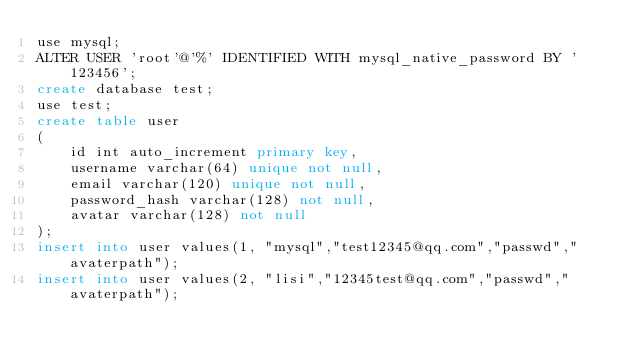Convert code to text. <code><loc_0><loc_0><loc_500><loc_500><_SQL_>use mysql;
ALTER USER 'root'@'%' IDENTIFIED WITH mysql_native_password BY '123456';
create database test;
use test;
create table user
(
    id int auto_increment primary key,
    username varchar(64) unique not null,
    email varchar(120) unique not null,
    password_hash varchar(128) not null,
    avatar varchar(128) not null
);
insert into user values(1, "mysql","test12345@qq.com","passwd","avaterpath");
insert into user values(2, "lisi","12345test@qq.com","passwd","avaterpath");
</code> 